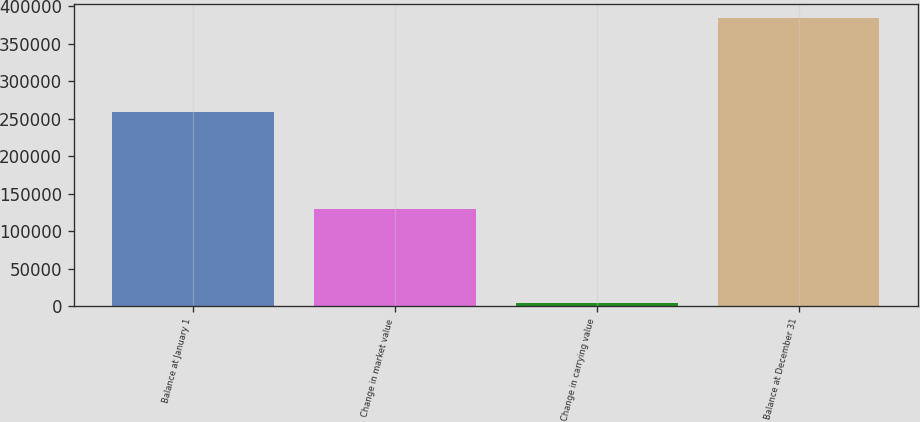Convert chart to OTSL. <chart><loc_0><loc_0><loc_500><loc_500><bar_chart><fcel>Balance at January 1<fcel>Change in market value<fcel>Change in carrying value<fcel>Balance at December 31<nl><fcel>258280<fcel>129918<fcel>4658<fcel>383540<nl></chart> 